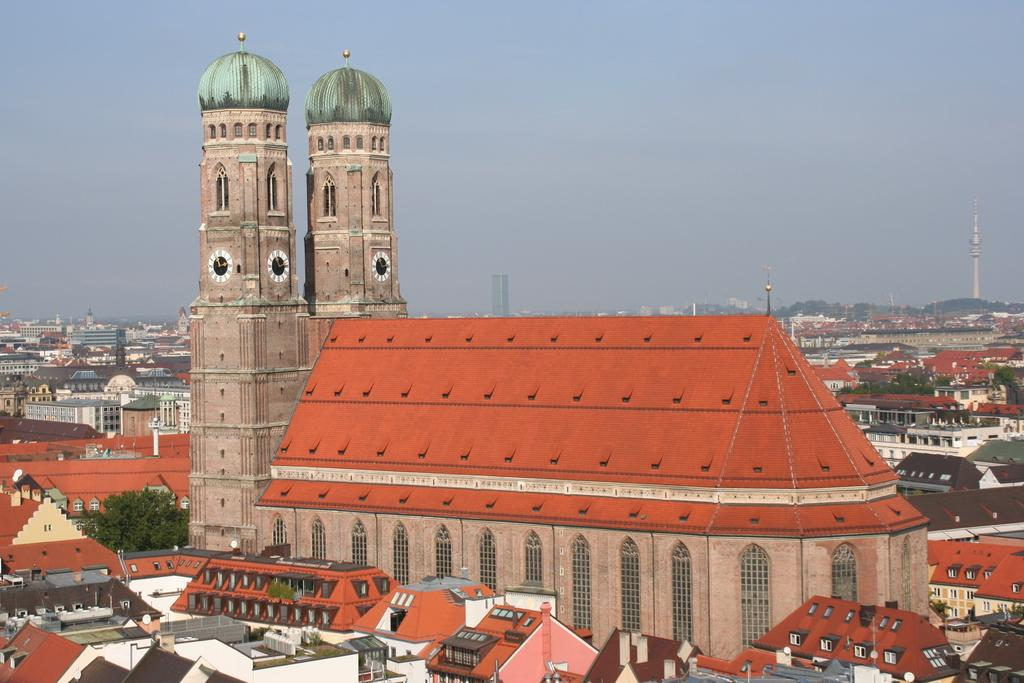What type of structures are present in the image? There are buildings and towers in the image. What can be seen in the background of the image? There are trees in the background of the image. How many children are playing with a chain in the image? There are no children or chains present in the image. What type of pleasure can be seen in the image? There is no indication of pleasure in the image; it features buildings, towers, and trees. 